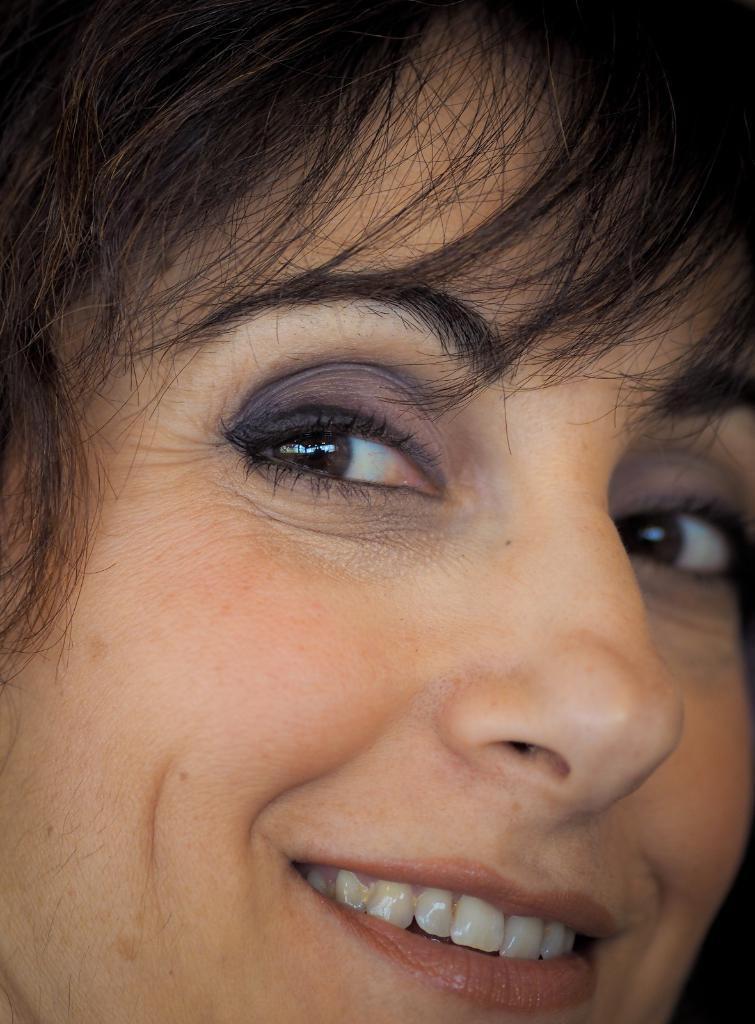What is the main subject in the foreground of the image? There is a woman in the foreground of the image. What is the woman doing in the image? The woman is smiling. What type of bun is the woman wearing in the image? There is no bun visible on the woman in the image. What part of the woman's body is twisted in the image? There is no part of the woman's body twisted in the image; she is simply smiling. 